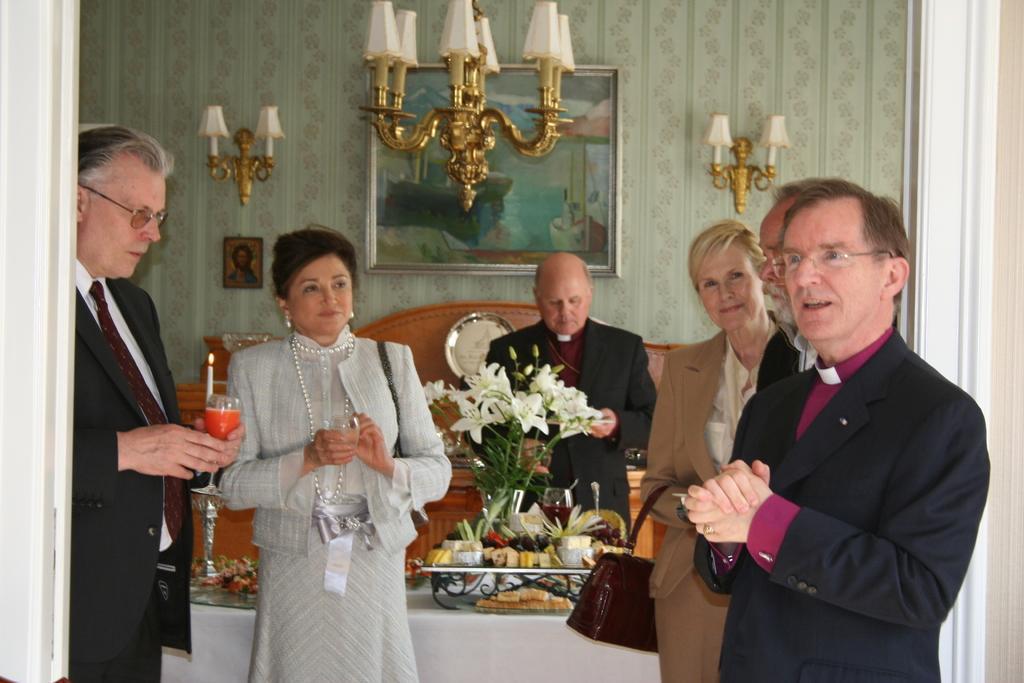Please provide a concise description of this image. In the picture I can see people are standing among them some are holding glasses in hands. In the background I can see a photo frame, lights, a clock and some other objects attached to the wall. I can also see a table which has food items, flowers and some other objects on it. 